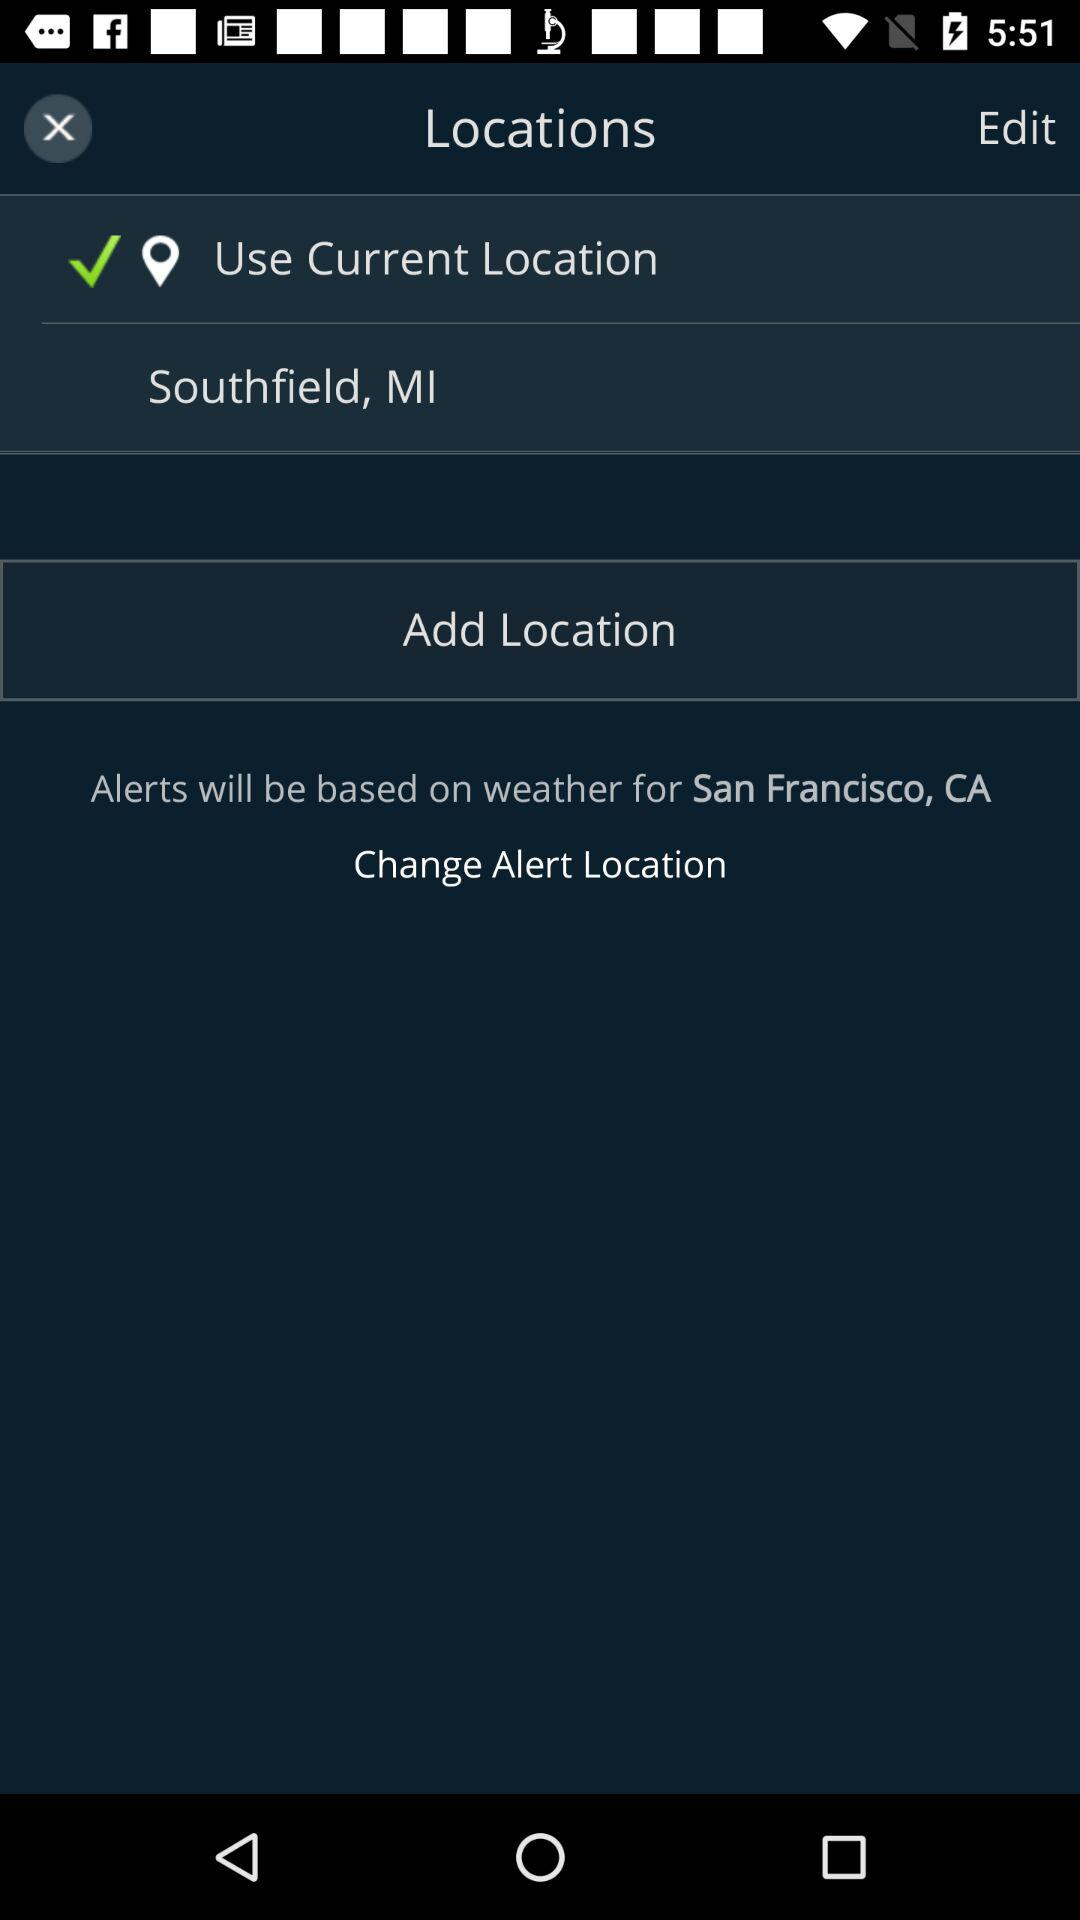How many more locations are there than alert locations?
Answer the question using a single word or phrase. 1 